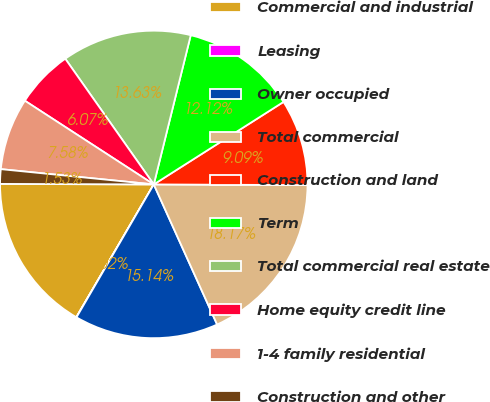<chart> <loc_0><loc_0><loc_500><loc_500><pie_chart><fcel>Commercial and industrial<fcel>Leasing<fcel>Owner occupied<fcel>Total commercial<fcel>Construction and land<fcel>Term<fcel>Total commercial real estate<fcel>Home equity credit line<fcel>1-4 family residential<fcel>Construction and other<nl><fcel>16.65%<fcel>0.02%<fcel>15.14%<fcel>18.17%<fcel>9.09%<fcel>12.12%<fcel>13.63%<fcel>6.07%<fcel>7.58%<fcel>1.53%<nl></chart> 